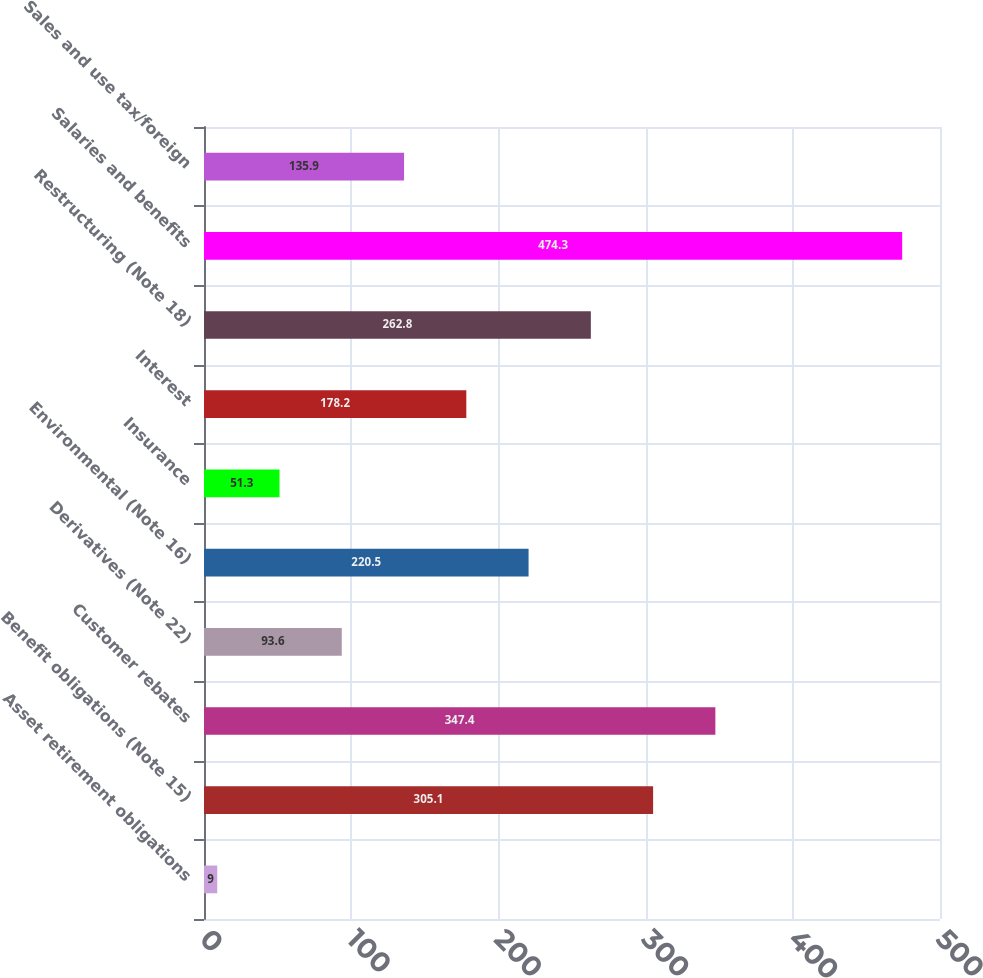Convert chart. <chart><loc_0><loc_0><loc_500><loc_500><bar_chart><fcel>Asset retirement obligations<fcel>Benefit obligations (Note 15)<fcel>Customer rebates<fcel>Derivatives (Note 22)<fcel>Environmental (Note 16)<fcel>Insurance<fcel>Interest<fcel>Restructuring (Note 18)<fcel>Salaries and benefits<fcel>Sales and use tax/foreign<nl><fcel>9<fcel>305.1<fcel>347.4<fcel>93.6<fcel>220.5<fcel>51.3<fcel>178.2<fcel>262.8<fcel>474.3<fcel>135.9<nl></chart> 